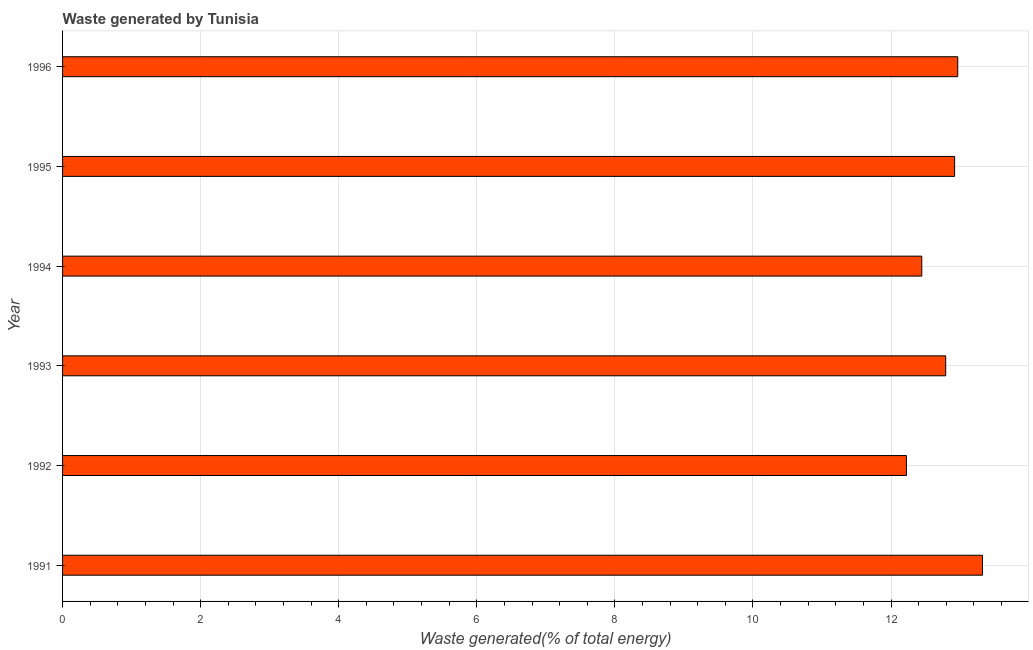Does the graph contain grids?
Make the answer very short. Yes. What is the title of the graph?
Provide a succinct answer. Waste generated by Tunisia. What is the label or title of the X-axis?
Provide a succinct answer. Waste generated(% of total energy). What is the label or title of the Y-axis?
Provide a succinct answer. Year. What is the amount of waste generated in 1991?
Provide a short and direct response. 13.33. Across all years, what is the maximum amount of waste generated?
Ensure brevity in your answer.  13.33. Across all years, what is the minimum amount of waste generated?
Give a very brief answer. 12.22. What is the sum of the amount of waste generated?
Your answer should be compact. 76.68. What is the difference between the amount of waste generated in 1993 and 1994?
Keep it short and to the point. 0.35. What is the average amount of waste generated per year?
Make the answer very short. 12.78. What is the median amount of waste generated?
Your answer should be very brief. 12.86. What is the ratio of the amount of waste generated in 1991 to that in 1995?
Your response must be concise. 1.03. Is the difference between the amount of waste generated in 1991 and 1993 greater than the difference between any two years?
Provide a short and direct response. No. What is the difference between the highest and the second highest amount of waste generated?
Offer a terse response. 0.36. Is the sum of the amount of waste generated in 1993 and 1996 greater than the maximum amount of waste generated across all years?
Ensure brevity in your answer.  Yes. What is the difference between the highest and the lowest amount of waste generated?
Provide a succinct answer. 1.1. How many years are there in the graph?
Ensure brevity in your answer.  6. Are the values on the major ticks of X-axis written in scientific E-notation?
Make the answer very short. No. What is the Waste generated(% of total energy) in 1991?
Give a very brief answer. 13.33. What is the Waste generated(% of total energy) of 1992?
Provide a short and direct response. 12.22. What is the Waste generated(% of total energy) in 1993?
Provide a succinct answer. 12.79. What is the Waste generated(% of total energy) in 1994?
Ensure brevity in your answer.  12.45. What is the Waste generated(% of total energy) of 1995?
Your answer should be very brief. 12.92. What is the Waste generated(% of total energy) in 1996?
Offer a very short reply. 12.97. What is the difference between the Waste generated(% of total energy) in 1991 and 1992?
Offer a very short reply. 1.1. What is the difference between the Waste generated(% of total energy) in 1991 and 1993?
Your answer should be very brief. 0.53. What is the difference between the Waste generated(% of total energy) in 1991 and 1994?
Offer a terse response. 0.88. What is the difference between the Waste generated(% of total energy) in 1991 and 1995?
Keep it short and to the point. 0.4. What is the difference between the Waste generated(% of total energy) in 1991 and 1996?
Ensure brevity in your answer.  0.36. What is the difference between the Waste generated(% of total energy) in 1992 and 1993?
Offer a very short reply. -0.57. What is the difference between the Waste generated(% of total energy) in 1992 and 1994?
Offer a terse response. -0.22. What is the difference between the Waste generated(% of total energy) in 1992 and 1995?
Offer a terse response. -0.7. What is the difference between the Waste generated(% of total energy) in 1992 and 1996?
Make the answer very short. -0.74. What is the difference between the Waste generated(% of total energy) in 1993 and 1994?
Your answer should be compact. 0.35. What is the difference between the Waste generated(% of total energy) in 1993 and 1995?
Your answer should be compact. -0.13. What is the difference between the Waste generated(% of total energy) in 1993 and 1996?
Offer a very short reply. -0.17. What is the difference between the Waste generated(% of total energy) in 1994 and 1995?
Provide a short and direct response. -0.48. What is the difference between the Waste generated(% of total energy) in 1994 and 1996?
Give a very brief answer. -0.52. What is the difference between the Waste generated(% of total energy) in 1995 and 1996?
Ensure brevity in your answer.  -0.05. What is the ratio of the Waste generated(% of total energy) in 1991 to that in 1992?
Ensure brevity in your answer.  1.09. What is the ratio of the Waste generated(% of total energy) in 1991 to that in 1993?
Make the answer very short. 1.04. What is the ratio of the Waste generated(% of total energy) in 1991 to that in 1994?
Provide a succinct answer. 1.07. What is the ratio of the Waste generated(% of total energy) in 1991 to that in 1995?
Keep it short and to the point. 1.03. What is the ratio of the Waste generated(% of total energy) in 1991 to that in 1996?
Make the answer very short. 1.03. What is the ratio of the Waste generated(% of total energy) in 1992 to that in 1993?
Keep it short and to the point. 0.96. What is the ratio of the Waste generated(% of total energy) in 1992 to that in 1995?
Make the answer very short. 0.95. What is the ratio of the Waste generated(% of total energy) in 1992 to that in 1996?
Your response must be concise. 0.94. What is the ratio of the Waste generated(% of total energy) in 1993 to that in 1994?
Provide a short and direct response. 1.03. What is the ratio of the Waste generated(% of total energy) in 1993 to that in 1995?
Keep it short and to the point. 0.99. What is the ratio of the Waste generated(% of total energy) in 1995 to that in 1996?
Your answer should be compact. 1. 